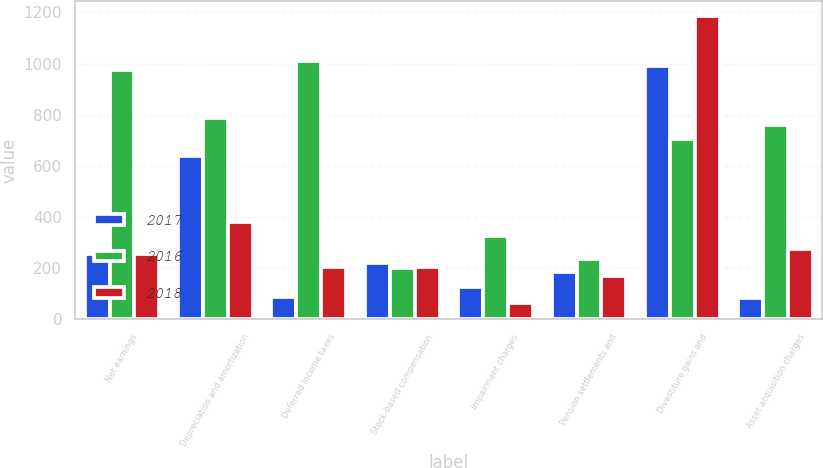Convert chart. <chart><loc_0><loc_0><loc_500><loc_500><stacked_bar_chart><ecel><fcel>Net earnings<fcel>Depreciation and amortization<fcel>Deferred income taxes<fcel>Stock-based compensation<fcel>Impairment charges<fcel>Pension settlements and<fcel>Divestiture gains and<fcel>Asset acquisition charges<nl><fcel>2017<fcel>255<fcel>637<fcel>86<fcel>221<fcel>126<fcel>186<fcel>992<fcel>85<nl><fcel>2016<fcel>975<fcel>789<fcel>1010<fcel>199<fcel>327<fcel>236<fcel>706<fcel>760<nl><fcel>2018<fcel>255<fcel>382<fcel>204<fcel>205<fcel>63<fcel>169<fcel>1187<fcel>274<nl></chart> 